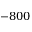Convert formula to latex. <formula><loc_0><loc_0><loc_500><loc_500>- 8 0 0</formula> 